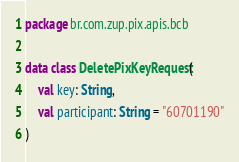<code> <loc_0><loc_0><loc_500><loc_500><_Kotlin_>package br.com.zup.pix.apis.bcb

data class DeletePixKeyRequest(
    val key: String,
    val participant: String = "60701190"
)
</code> 